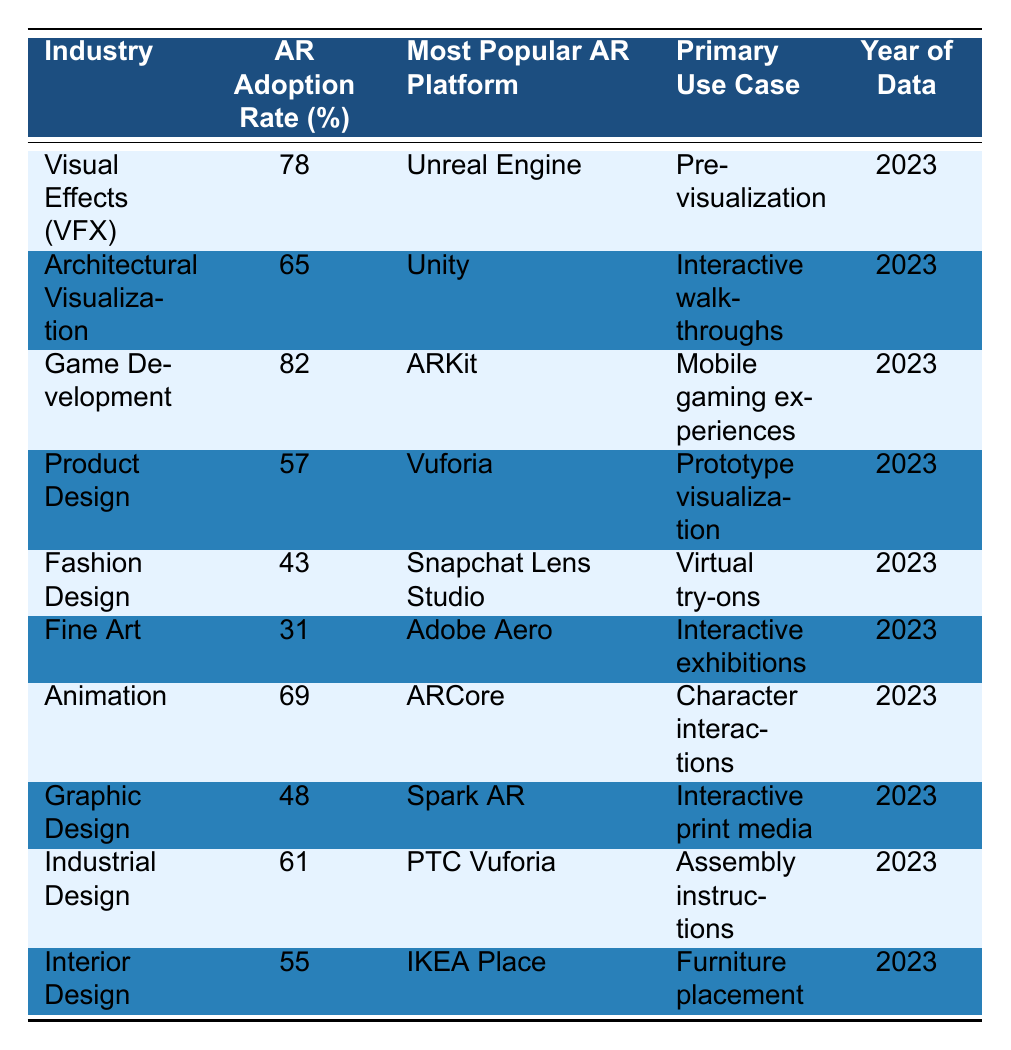What is the AR adoption rate in the Fashion Design industry? The table shows that the AR adoption rate for the Fashion Design industry is 43%.
Answer: 43% Which industry has the highest AR adoption rate? The Game Development industry has the highest AR adoption rate at 82%.
Answer: Game Development What is the most popular AR platform for Architectural Visualization? According to the table, the most popular AR platform for Architectural Visualization is Unity.
Answer: Unity Is the AR adoption rate in Fine Art higher than that in Graphic Design? The table lists the AR adoption rate for Fine Art as 31% and for Graphic Design as 48%. Since 31% is less than 48%, the statement is false.
Answer: No What are the primary use cases for AR in Animation and Interior Design? The primary use case for Animation is character interactions, while for Interior Design, it is furniture placement.
Answer: Character interactions and furniture placement What is the average AR adoption rate of the listed industries? To find the average adoption rate, sum the rates: (78 + 65 + 82 + 57 + 43 + 31 + 69 + 48 + 61 + 55) =  489. There are 10 industries, so the average is 489/10 = 48.9%.
Answer: 48.9% Which two industries have the same primary use case related to interactive experiences? The Fine Art industry uses AR for interactive exhibitions, and the Graphic Design industry uses it for interactive print media. Neither shares the same primary use case, making the statement false.
Answer: None What is the difference in AR adoption rates between Game Development and Product Design? Game Development has an adoption rate of 82% and Product Design has 57%. The difference is 82% - 57% = 25%.
Answer: 25% Which industry uses Adobe Aero as its most popular AR platform? The Fine Art industry uses Adobe Aero as its most popular AR platform.
Answer: Fine Art Do most industries listed in the table focus on mobile AR applications? The table shows various use cases, but only Game Development clearly states a focus on mobile gaming experiences. Other industries focus on different applications, so the statement is false overall.
Answer: No 